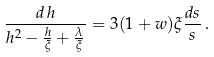Convert formula to latex. <formula><loc_0><loc_0><loc_500><loc_500>\frac { d \, h } { h ^ { 2 } - \frac { h } { \xi } + \frac { \lambda } { \xi } } = 3 ( 1 + w ) \xi \frac { d s } { s } \, .</formula> 